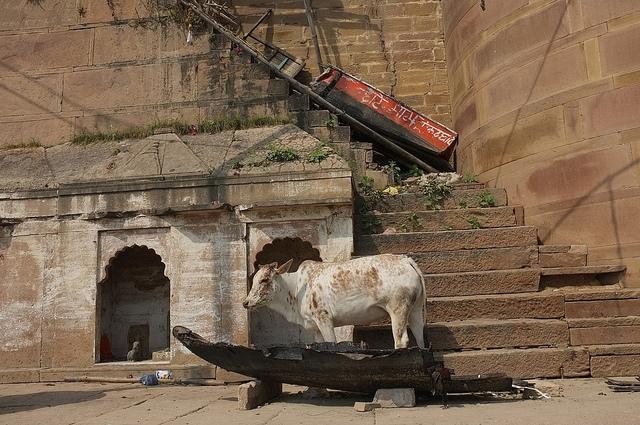How many people are wearing pink pants?
Give a very brief answer. 0. 